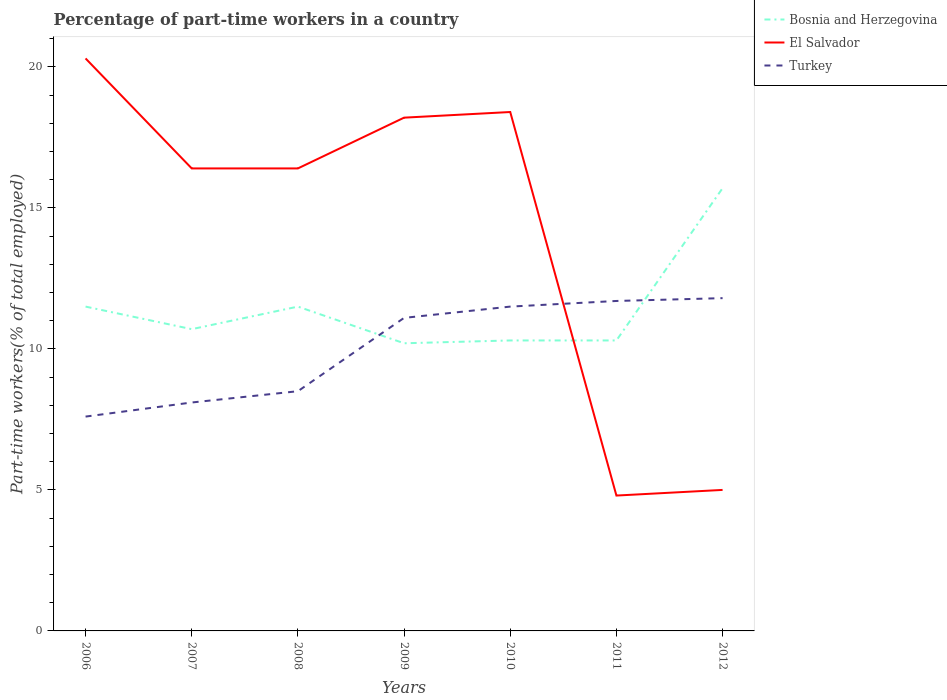Across all years, what is the maximum percentage of part-time workers in Turkey?
Make the answer very short. 7.6. In which year was the percentage of part-time workers in El Salvador maximum?
Your answer should be compact. 2011. What is the total percentage of part-time workers in Turkey in the graph?
Your response must be concise. -3.2. What is the difference between the highest and the second highest percentage of part-time workers in El Salvador?
Offer a terse response. 15.5. What is the difference between the highest and the lowest percentage of part-time workers in Bosnia and Herzegovina?
Offer a very short reply. 3. Is the percentage of part-time workers in Bosnia and Herzegovina strictly greater than the percentage of part-time workers in Turkey over the years?
Provide a short and direct response. No. How many lines are there?
Make the answer very short. 3. How many years are there in the graph?
Your answer should be compact. 7. Does the graph contain any zero values?
Give a very brief answer. No. Where does the legend appear in the graph?
Provide a short and direct response. Top right. What is the title of the graph?
Ensure brevity in your answer.  Percentage of part-time workers in a country. Does "Macedonia" appear as one of the legend labels in the graph?
Provide a succinct answer. No. What is the label or title of the X-axis?
Offer a very short reply. Years. What is the label or title of the Y-axis?
Offer a terse response. Part-time workers(% of total employed). What is the Part-time workers(% of total employed) in Bosnia and Herzegovina in 2006?
Your response must be concise. 11.5. What is the Part-time workers(% of total employed) of El Salvador in 2006?
Your response must be concise. 20.3. What is the Part-time workers(% of total employed) in Turkey in 2006?
Your response must be concise. 7.6. What is the Part-time workers(% of total employed) in Bosnia and Herzegovina in 2007?
Offer a terse response. 10.7. What is the Part-time workers(% of total employed) in El Salvador in 2007?
Keep it short and to the point. 16.4. What is the Part-time workers(% of total employed) of Turkey in 2007?
Provide a short and direct response. 8.1. What is the Part-time workers(% of total employed) in Bosnia and Herzegovina in 2008?
Your answer should be very brief. 11.5. What is the Part-time workers(% of total employed) of El Salvador in 2008?
Provide a succinct answer. 16.4. What is the Part-time workers(% of total employed) of Bosnia and Herzegovina in 2009?
Provide a short and direct response. 10.2. What is the Part-time workers(% of total employed) of El Salvador in 2009?
Make the answer very short. 18.2. What is the Part-time workers(% of total employed) in Turkey in 2009?
Your answer should be very brief. 11.1. What is the Part-time workers(% of total employed) in Bosnia and Herzegovina in 2010?
Offer a terse response. 10.3. What is the Part-time workers(% of total employed) of El Salvador in 2010?
Provide a succinct answer. 18.4. What is the Part-time workers(% of total employed) of Bosnia and Herzegovina in 2011?
Your answer should be very brief. 10.3. What is the Part-time workers(% of total employed) in El Salvador in 2011?
Your answer should be compact. 4.8. What is the Part-time workers(% of total employed) in Turkey in 2011?
Your answer should be very brief. 11.7. What is the Part-time workers(% of total employed) of Bosnia and Herzegovina in 2012?
Provide a short and direct response. 15.7. What is the Part-time workers(% of total employed) of Turkey in 2012?
Make the answer very short. 11.8. Across all years, what is the maximum Part-time workers(% of total employed) of Bosnia and Herzegovina?
Ensure brevity in your answer.  15.7. Across all years, what is the maximum Part-time workers(% of total employed) of El Salvador?
Provide a short and direct response. 20.3. Across all years, what is the maximum Part-time workers(% of total employed) in Turkey?
Ensure brevity in your answer.  11.8. Across all years, what is the minimum Part-time workers(% of total employed) in Bosnia and Herzegovina?
Keep it short and to the point. 10.2. Across all years, what is the minimum Part-time workers(% of total employed) of El Salvador?
Keep it short and to the point. 4.8. Across all years, what is the minimum Part-time workers(% of total employed) in Turkey?
Make the answer very short. 7.6. What is the total Part-time workers(% of total employed) of Bosnia and Herzegovina in the graph?
Your answer should be very brief. 80.2. What is the total Part-time workers(% of total employed) in El Salvador in the graph?
Your answer should be compact. 99.5. What is the total Part-time workers(% of total employed) in Turkey in the graph?
Give a very brief answer. 70.3. What is the difference between the Part-time workers(% of total employed) in Bosnia and Herzegovina in 2006 and that in 2007?
Make the answer very short. 0.8. What is the difference between the Part-time workers(% of total employed) of Bosnia and Herzegovina in 2006 and that in 2008?
Offer a very short reply. 0. What is the difference between the Part-time workers(% of total employed) of Bosnia and Herzegovina in 2006 and that in 2010?
Offer a terse response. 1.2. What is the difference between the Part-time workers(% of total employed) in El Salvador in 2006 and that in 2011?
Ensure brevity in your answer.  15.5. What is the difference between the Part-time workers(% of total employed) in El Salvador in 2006 and that in 2012?
Offer a very short reply. 15.3. What is the difference between the Part-time workers(% of total employed) in Turkey in 2006 and that in 2012?
Provide a succinct answer. -4.2. What is the difference between the Part-time workers(% of total employed) in El Salvador in 2007 and that in 2008?
Provide a succinct answer. 0. What is the difference between the Part-time workers(% of total employed) of Turkey in 2007 and that in 2009?
Provide a succinct answer. -3. What is the difference between the Part-time workers(% of total employed) of Bosnia and Herzegovina in 2007 and that in 2010?
Offer a very short reply. 0.4. What is the difference between the Part-time workers(% of total employed) in El Salvador in 2007 and that in 2010?
Your answer should be compact. -2. What is the difference between the Part-time workers(% of total employed) of Turkey in 2007 and that in 2010?
Keep it short and to the point. -3.4. What is the difference between the Part-time workers(% of total employed) of El Salvador in 2007 and that in 2011?
Offer a very short reply. 11.6. What is the difference between the Part-time workers(% of total employed) of Bosnia and Herzegovina in 2007 and that in 2012?
Offer a very short reply. -5. What is the difference between the Part-time workers(% of total employed) in El Salvador in 2007 and that in 2012?
Provide a succinct answer. 11.4. What is the difference between the Part-time workers(% of total employed) of Turkey in 2007 and that in 2012?
Offer a terse response. -3.7. What is the difference between the Part-time workers(% of total employed) of Bosnia and Herzegovina in 2008 and that in 2009?
Make the answer very short. 1.3. What is the difference between the Part-time workers(% of total employed) in Turkey in 2008 and that in 2011?
Keep it short and to the point. -3.2. What is the difference between the Part-time workers(% of total employed) of Bosnia and Herzegovina in 2008 and that in 2012?
Offer a terse response. -4.2. What is the difference between the Part-time workers(% of total employed) in Bosnia and Herzegovina in 2009 and that in 2011?
Offer a very short reply. -0.1. What is the difference between the Part-time workers(% of total employed) in El Salvador in 2009 and that in 2011?
Offer a terse response. 13.4. What is the difference between the Part-time workers(% of total employed) of Turkey in 2009 and that in 2011?
Keep it short and to the point. -0.6. What is the difference between the Part-time workers(% of total employed) in El Salvador in 2009 and that in 2012?
Provide a short and direct response. 13.2. What is the difference between the Part-time workers(% of total employed) of Turkey in 2009 and that in 2012?
Offer a very short reply. -0.7. What is the difference between the Part-time workers(% of total employed) of El Salvador in 2010 and that in 2011?
Ensure brevity in your answer.  13.6. What is the difference between the Part-time workers(% of total employed) in Turkey in 2010 and that in 2011?
Offer a terse response. -0.2. What is the difference between the Part-time workers(% of total employed) of Bosnia and Herzegovina in 2010 and that in 2012?
Your answer should be compact. -5.4. What is the difference between the Part-time workers(% of total employed) in Bosnia and Herzegovina in 2011 and that in 2012?
Make the answer very short. -5.4. What is the difference between the Part-time workers(% of total employed) of El Salvador in 2011 and that in 2012?
Ensure brevity in your answer.  -0.2. What is the difference between the Part-time workers(% of total employed) in Bosnia and Herzegovina in 2006 and the Part-time workers(% of total employed) in El Salvador in 2007?
Your answer should be very brief. -4.9. What is the difference between the Part-time workers(% of total employed) of Bosnia and Herzegovina in 2006 and the Part-time workers(% of total employed) of Turkey in 2007?
Your response must be concise. 3.4. What is the difference between the Part-time workers(% of total employed) of Bosnia and Herzegovina in 2006 and the Part-time workers(% of total employed) of Turkey in 2008?
Provide a succinct answer. 3. What is the difference between the Part-time workers(% of total employed) in El Salvador in 2006 and the Part-time workers(% of total employed) in Turkey in 2008?
Your answer should be very brief. 11.8. What is the difference between the Part-time workers(% of total employed) of Bosnia and Herzegovina in 2006 and the Part-time workers(% of total employed) of El Salvador in 2009?
Keep it short and to the point. -6.7. What is the difference between the Part-time workers(% of total employed) of Bosnia and Herzegovina in 2006 and the Part-time workers(% of total employed) of Turkey in 2009?
Your answer should be very brief. 0.4. What is the difference between the Part-time workers(% of total employed) of El Salvador in 2006 and the Part-time workers(% of total employed) of Turkey in 2010?
Provide a succinct answer. 8.8. What is the difference between the Part-time workers(% of total employed) in Bosnia and Herzegovina in 2006 and the Part-time workers(% of total employed) in El Salvador in 2011?
Offer a terse response. 6.7. What is the difference between the Part-time workers(% of total employed) of Bosnia and Herzegovina in 2007 and the Part-time workers(% of total employed) of El Salvador in 2008?
Keep it short and to the point. -5.7. What is the difference between the Part-time workers(% of total employed) in Bosnia and Herzegovina in 2007 and the Part-time workers(% of total employed) in Turkey in 2008?
Offer a very short reply. 2.2. What is the difference between the Part-time workers(% of total employed) of El Salvador in 2007 and the Part-time workers(% of total employed) of Turkey in 2008?
Provide a short and direct response. 7.9. What is the difference between the Part-time workers(% of total employed) of Bosnia and Herzegovina in 2007 and the Part-time workers(% of total employed) of El Salvador in 2009?
Your response must be concise. -7.5. What is the difference between the Part-time workers(% of total employed) of El Salvador in 2007 and the Part-time workers(% of total employed) of Turkey in 2009?
Offer a terse response. 5.3. What is the difference between the Part-time workers(% of total employed) in Bosnia and Herzegovina in 2007 and the Part-time workers(% of total employed) in Turkey in 2010?
Provide a succinct answer. -0.8. What is the difference between the Part-time workers(% of total employed) in El Salvador in 2007 and the Part-time workers(% of total employed) in Turkey in 2010?
Offer a very short reply. 4.9. What is the difference between the Part-time workers(% of total employed) of Bosnia and Herzegovina in 2007 and the Part-time workers(% of total employed) of El Salvador in 2011?
Your response must be concise. 5.9. What is the difference between the Part-time workers(% of total employed) in Bosnia and Herzegovina in 2007 and the Part-time workers(% of total employed) in Turkey in 2011?
Your answer should be compact. -1. What is the difference between the Part-time workers(% of total employed) in El Salvador in 2007 and the Part-time workers(% of total employed) in Turkey in 2011?
Make the answer very short. 4.7. What is the difference between the Part-time workers(% of total employed) of Bosnia and Herzegovina in 2007 and the Part-time workers(% of total employed) of El Salvador in 2012?
Provide a short and direct response. 5.7. What is the difference between the Part-time workers(% of total employed) of El Salvador in 2007 and the Part-time workers(% of total employed) of Turkey in 2012?
Your answer should be very brief. 4.6. What is the difference between the Part-time workers(% of total employed) of Bosnia and Herzegovina in 2008 and the Part-time workers(% of total employed) of Turkey in 2009?
Provide a succinct answer. 0.4. What is the difference between the Part-time workers(% of total employed) of El Salvador in 2008 and the Part-time workers(% of total employed) of Turkey in 2009?
Give a very brief answer. 5.3. What is the difference between the Part-time workers(% of total employed) of Bosnia and Herzegovina in 2008 and the Part-time workers(% of total employed) of El Salvador in 2010?
Make the answer very short. -6.9. What is the difference between the Part-time workers(% of total employed) in El Salvador in 2008 and the Part-time workers(% of total employed) in Turkey in 2010?
Provide a succinct answer. 4.9. What is the difference between the Part-time workers(% of total employed) in Bosnia and Herzegovina in 2009 and the Part-time workers(% of total employed) in El Salvador in 2010?
Offer a terse response. -8.2. What is the difference between the Part-time workers(% of total employed) of El Salvador in 2009 and the Part-time workers(% of total employed) of Turkey in 2010?
Keep it short and to the point. 6.7. What is the difference between the Part-time workers(% of total employed) in Bosnia and Herzegovina in 2009 and the Part-time workers(% of total employed) in El Salvador in 2011?
Offer a terse response. 5.4. What is the difference between the Part-time workers(% of total employed) in El Salvador in 2009 and the Part-time workers(% of total employed) in Turkey in 2011?
Your response must be concise. 6.5. What is the difference between the Part-time workers(% of total employed) of Bosnia and Herzegovina in 2009 and the Part-time workers(% of total employed) of El Salvador in 2012?
Your answer should be very brief. 5.2. What is the difference between the Part-time workers(% of total employed) in El Salvador in 2009 and the Part-time workers(% of total employed) in Turkey in 2012?
Offer a very short reply. 6.4. What is the difference between the Part-time workers(% of total employed) of Bosnia and Herzegovina in 2010 and the Part-time workers(% of total employed) of Turkey in 2011?
Make the answer very short. -1.4. What is the difference between the Part-time workers(% of total employed) of Bosnia and Herzegovina in 2011 and the Part-time workers(% of total employed) of El Salvador in 2012?
Provide a succinct answer. 5.3. What is the difference between the Part-time workers(% of total employed) in Bosnia and Herzegovina in 2011 and the Part-time workers(% of total employed) in Turkey in 2012?
Provide a short and direct response. -1.5. What is the average Part-time workers(% of total employed) of Bosnia and Herzegovina per year?
Make the answer very short. 11.46. What is the average Part-time workers(% of total employed) of El Salvador per year?
Your answer should be very brief. 14.21. What is the average Part-time workers(% of total employed) in Turkey per year?
Your answer should be compact. 10.04. In the year 2007, what is the difference between the Part-time workers(% of total employed) of Bosnia and Herzegovina and Part-time workers(% of total employed) of El Salvador?
Keep it short and to the point. -5.7. In the year 2007, what is the difference between the Part-time workers(% of total employed) in El Salvador and Part-time workers(% of total employed) in Turkey?
Ensure brevity in your answer.  8.3. In the year 2008, what is the difference between the Part-time workers(% of total employed) of El Salvador and Part-time workers(% of total employed) of Turkey?
Make the answer very short. 7.9. In the year 2009, what is the difference between the Part-time workers(% of total employed) in Bosnia and Herzegovina and Part-time workers(% of total employed) in Turkey?
Ensure brevity in your answer.  -0.9. In the year 2010, what is the difference between the Part-time workers(% of total employed) in El Salvador and Part-time workers(% of total employed) in Turkey?
Ensure brevity in your answer.  6.9. In the year 2011, what is the difference between the Part-time workers(% of total employed) of Bosnia and Herzegovina and Part-time workers(% of total employed) of El Salvador?
Your answer should be very brief. 5.5. In the year 2011, what is the difference between the Part-time workers(% of total employed) in El Salvador and Part-time workers(% of total employed) in Turkey?
Offer a very short reply. -6.9. In the year 2012, what is the difference between the Part-time workers(% of total employed) in Bosnia and Herzegovina and Part-time workers(% of total employed) in El Salvador?
Make the answer very short. 10.7. In the year 2012, what is the difference between the Part-time workers(% of total employed) in El Salvador and Part-time workers(% of total employed) in Turkey?
Provide a succinct answer. -6.8. What is the ratio of the Part-time workers(% of total employed) of Bosnia and Herzegovina in 2006 to that in 2007?
Keep it short and to the point. 1.07. What is the ratio of the Part-time workers(% of total employed) of El Salvador in 2006 to that in 2007?
Give a very brief answer. 1.24. What is the ratio of the Part-time workers(% of total employed) of Turkey in 2006 to that in 2007?
Offer a terse response. 0.94. What is the ratio of the Part-time workers(% of total employed) in Bosnia and Herzegovina in 2006 to that in 2008?
Provide a succinct answer. 1. What is the ratio of the Part-time workers(% of total employed) of El Salvador in 2006 to that in 2008?
Your response must be concise. 1.24. What is the ratio of the Part-time workers(% of total employed) of Turkey in 2006 to that in 2008?
Give a very brief answer. 0.89. What is the ratio of the Part-time workers(% of total employed) in Bosnia and Herzegovina in 2006 to that in 2009?
Keep it short and to the point. 1.13. What is the ratio of the Part-time workers(% of total employed) in El Salvador in 2006 to that in 2009?
Your answer should be compact. 1.12. What is the ratio of the Part-time workers(% of total employed) in Turkey in 2006 to that in 2009?
Provide a succinct answer. 0.68. What is the ratio of the Part-time workers(% of total employed) in Bosnia and Herzegovina in 2006 to that in 2010?
Provide a succinct answer. 1.12. What is the ratio of the Part-time workers(% of total employed) of El Salvador in 2006 to that in 2010?
Give a very brief answer. 1.1. What is the ratio of the Part-time workers(% of total employed) in Turkey in 2006 to that in 2010?
Provide a short and direct response. 0.66. What is the ratio of the Part-time workers(% of total employed) of Bosnia and Herzegovina in 2006 to that in 2011?
Make the answer very short. 1.12. What is the ratio of the Part-time workers(% of total employed) of El Salvador in 2006 to that in 2011?
Your response must be concise. 4.23. What is the ratio of the Part-time workers(% of total employed) of Turkey in 2006 to that in 2011?
Offer a very short reply. 0.65. What is the ratio of the Part-time workers(% of total employed) in Bosnia and Herzegovina in 2006 to that in 2012?
Give a very brief answer. 0.73. What is the ratio of the Part-time workers(% of total employed) of El Salvador in 2006 to that in 2012?
Your answer should be very brief. 4.06. What is the ratio of the Part-time workers(% of total employed) in Turkey in 2006 to that in 2012?
Your answer should be compact. 0.64. What is the ratio of the Part-time workers(% of total employed) of Bosnia and Herzegovina in 2007 to that in 2008?
Keep it short and to the point. 0.93. What is the ratio of the Part-time workers(% of total employed) in El Salvador in 2007 to that in 2008?
Give a very brief answer. 1. What is the ratio of the Part-time workers(% of total employed) in Turkey in 2007 to that in 2008?
Your response must be concise. 0.95. What is the ratio of the Part-time workers(% of total employed) in Bosnia and Herzegovina in 2007 to that in 2009?
Your answer should be compact. 1.05. What is the ratio of the Part-time workers(% of total employed) of El Salvador in 2007 to that in 2009?
Ensure brevity in your answer.  0.9. What is the ratio of the Part-time workers(% of total employed) in Turkey in 2007 to that in 2009?
Provide a succinct answer. 0.73. What is the ratio of the Part-time workers(% of total employed) of Bosnia and Herzegovina in 2007 to that in 2010?
Provide a succinct answer. 1.04. What is the ratio of the Part-time workers(% of total employed) in El Salvador in 2007 to that in 2010?
Keep it short and to the point. 0.89. What is the ratio of the Part-time workers(% of total employed) of Turkey in 2007 to that in 2010?
Ensure brevity in your answer.  0.7. What is the ratio of the Part-time workers(% of total employed) in Bosnia and Herzegovina in 2007 to that in 2011?
Keep it short and to the point. 1.04. What is the ratio of the Part-time workers(% of total employed) of El Salvador in 2007 to that in 2011?
Provide a succinct answer. 3.42. What is the ratio of the Part-time workers(% of total employed) in Turkey in 2007 to that in 2011?
Ensure brevity in your answer.  0.69. What is the ratio of the Part-time workers(% of total employed) in Bosnia and Herzegovina in 2007 to that in 2012?
Keep it short and to the point. 0.68. What is the ratio of the Part-time workers(% of total employed) in El Salvador in 2007 to that in 2012?
Your response must be concise. 3.28. What is the ratio of the Part-time workers(% of total employed) in Turkey in 2007 to that in 2012?
Your answer should be compact. 0.69. What is the ratio of the Part-time workers(% of total employed) of Bosnia and Herzegovina in 2008 to that in 2009?
Provide a succinct answer. 1.13. What is the ratio of the Part-time workers(% of total employed) of El Salvador in 2008 to that in 2009?
Offer a terse response. 0.9. What is the ratio of the Part-time workers(% of total employed) of Turkey in 2008 to that in 2009?
Make the answer very short. 0.77. What is the ratio of the Part-time workers(% of total employed) in Bosnia and Herzegovina in 2008 to that in 2010?
Provide a succinct answer. 1.12. What is the ratio of the Part-time workers(% of total employed) of El Salvador in 2008 to that in 2010?
Give a very brief answer. 0.89. What is the ratio of the Part-time workers(% of total employed) of Turkey in 2008 to that in 2010?
Your response must be concise. 0.74. What is the ratio of the Part-time workers(% of total employed) in Bosnia and Herzegovina in 2008 to that in 2011?
Your answer should be very brief. 1.12. What is the ratio of the Part-time workers(% of total employed) in El Salvador in 2008 to that in 2011?
Your answer should be compact. 3.42. What is the ratio of the Part-time workers(% of total employed) of Turkey in 2008 to that in 2011?
Keep it short and to the point. 0.73. What is the ratio of the Part-time workers(% of total employed) of Bosnia and Herzegovina in 2008 to that in 2012?
Keep it short and to the point. 0.73. What is the ratio of the Part-time workers(% of total employed) of El Salvador in 2008 to that in 2012?
Ensure brevity in your answer.  3.28. What is the ratio of the Part-time workers(% of total employed) of Turkey in 2008 to that in 2012?
Your answer should be very brief. 0.72. What is the ratio of the Part-time workers(% of total employed) of Bosnia and Herzegovina in 2009 to that in 2010?
Make the answer very short. 0.99. What is the ratio of the Part-time workers(% of total employed) of Turkey in 2009 to that in 2010?
Provide a succinct answer. 0.97. What is the ratio of the Part-time workers(% of total employed) in Bosnia and Herzegovina in 2009 to that in 2011?
Make the answer very short. 0.99. What is the ratio of the Part-time workers(% of total employed) in El Salvador in 2009 to that in 2011?
Your answer should be compact. 3.79. What is the ratio of the Part-time workers(% of total employed) in Turkey in 2009 to that in 2011?
Give a very brief answer. 0.95. What is the ratio of the Part-time workers(% of total employed) of Bosnia and Herzegovina in 2009 to that in 2012?
Provide a short and direct response. 0.65. What is the ratio of the Part-time workers(% of total employed) in El Salvador in 2009 to that in 2012?
Keep it short and to the point. 3.64. What is the ratio of the Part-time workers(% of total employed) in Turkey in 2009 to that in 2012?
Your response must be concise. 0.94. What is the ratio of the Part-time workers(% of total employed) in El Salvador in 2010 to that in 2011?
Your answer should be very brief. 3.83. What is the ratio of the Part-time workers(% of total employed) of Turkey in 2010 to that in 2011?
Make the answer very short. 0.98. What is the ratio of the Part-time workers(% of total employed) in Bosnia and Herzegovina in 2010 to that in 2012?
Your answer should be compact. 0.66. What is the ratio of the Part-time workers(% of total employed) of El Salvador in 2010 to that in 2012?
Make the answer very short. 3.68. What is the ratio of the Part-time workers(% of total employed) in Turkey in 2010 to that in 2012?
Your answer should be very brief. 0.97. What is the ratio of the Part-time workers(% of total employed) in Bosnia and Herzegovina in 2011 to that in 2012?
Provide a succinct answer. 0.66. What is the ratio of the Part-time workers(% of total employed) of El Salvador in 2011 to that in 2012?
Offer a terse response. 0.96. What is the ratio of the Part-time workers(% of total employed) of Turkey in 2011 to that in 2012?
Provide a succinct answer. 0.99. What is the difference between the highest and the second highest Part-time workers(% of total employed) of Turkey?
Provide a short and direct response. 0.1. What is the difference between the highest and the lowest Part-time workers(% of total employed) in Turkey?
Offer a terse response. 4.2. 